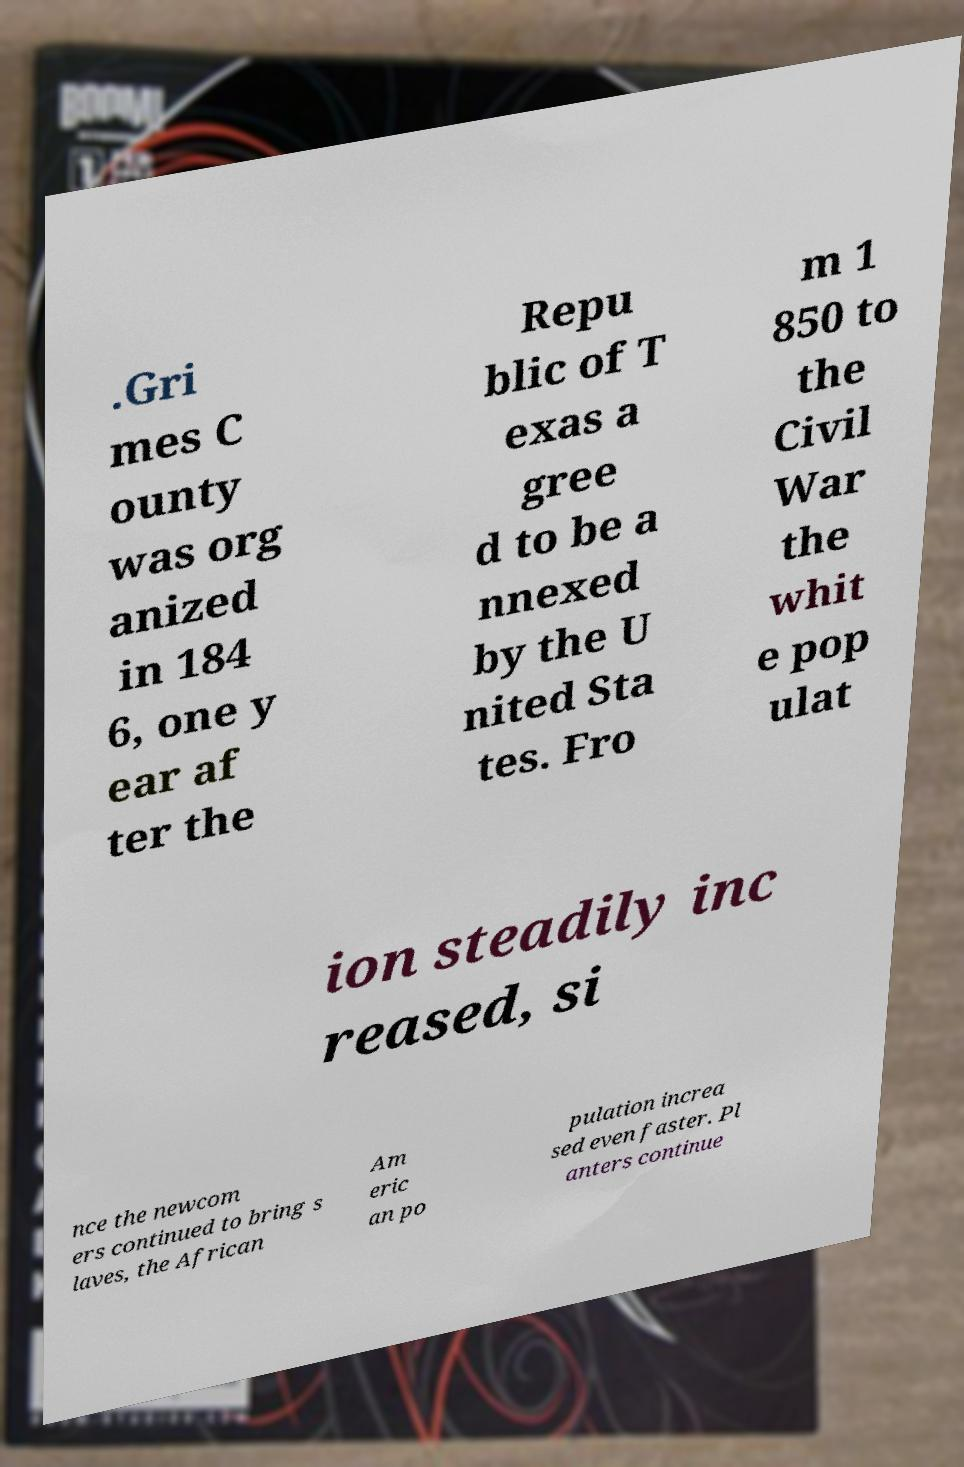What messages or text are displayed in this image? I need them in a readable, typed format. .Gri mes C ounty was org anized in 184 6, one y ear af ter the Repu blic of T exas a gree d to be a nnexed by the U nited Sta tes. Fro m 1 850 to the Civil War the whit e pop ulat ion steadily inc reased, si nce the newcom ers continued to bring s laves, the African Am eric an po pulation increa sed even faster. Pl anters continue 